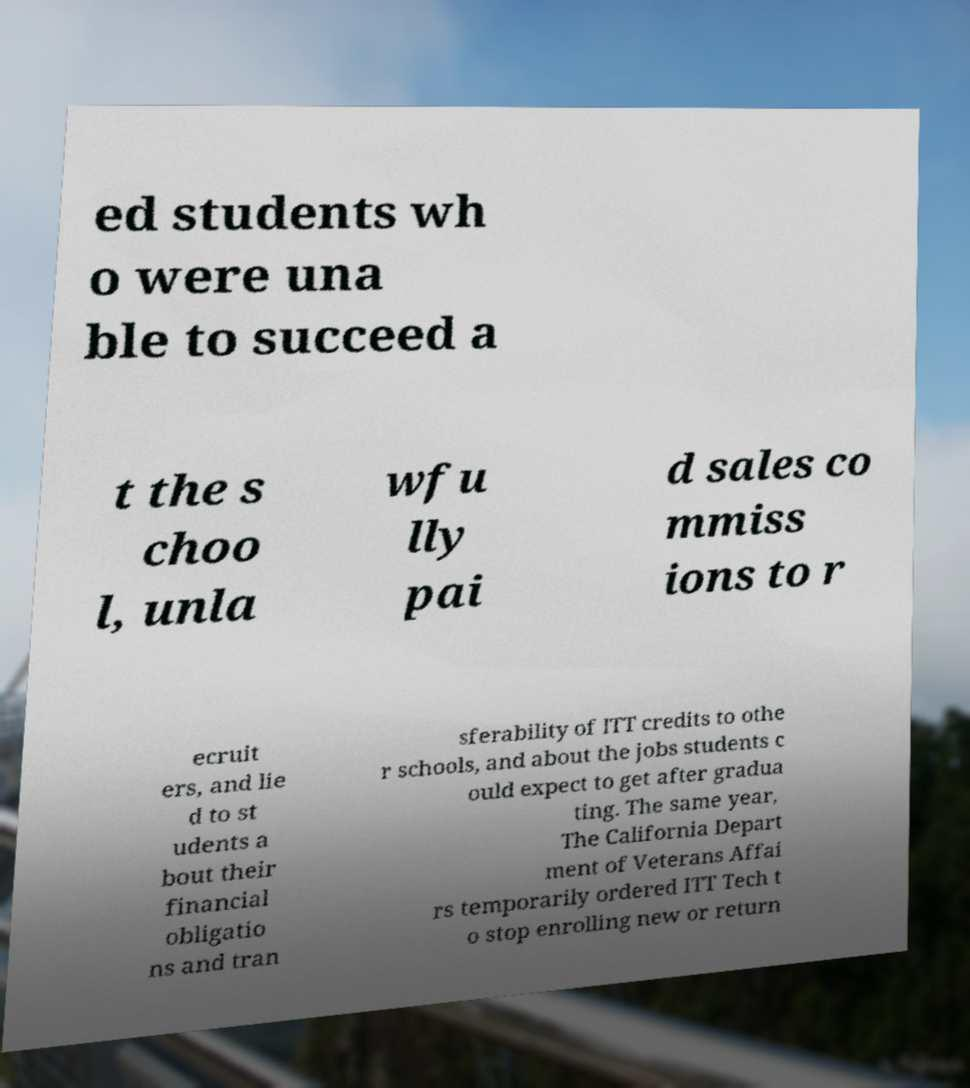Can you read and provide the text displayed in the image?This photo seems to have some interesting text. Can you extract and type it out for me? ed students wh o were una ble to succeed a t the s choo l, unla wfu lly pai d sales co mmiss ions to r ecruit ers, and lie d to st udents a bout their financial obligatio ns and tran sferability of ITT credits to othe r schools, and about the jobs students c ould expect to get after gradua ting. The same year, The California Depart ment of Veterans Affai rs temporarily ordered ITT Tech t o stop enrolling new or return 